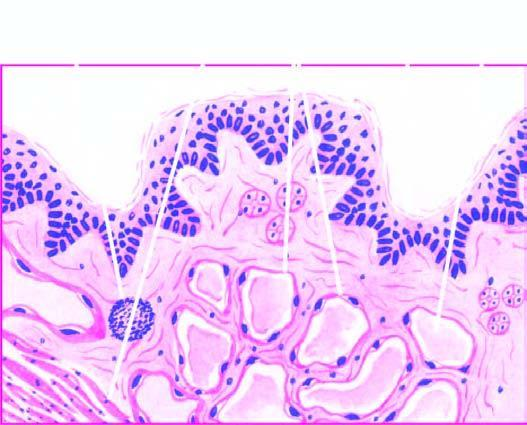what are present?
Answer the question using a single word or phrase. Large cystic spaces 